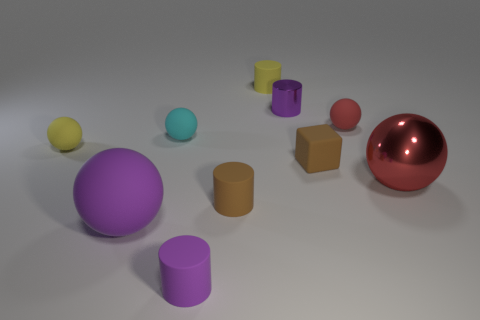Is there any other thing that is the same color as the small rubber block?
Offer a terse response. Yes. There is a cylinder that is the same color as the tiny block; what material is it?
Your answer should be compact. Rubber. The red metallic thing that is the same size as the purple ball is what shape?
Ensure brevity in your answer.  Sphere. What number of other objects are there of the same color as the metal sphere?
Your answer should be compact. 1. What number of cyan matte objects are there?
Offer a very short reply. 1. What number of matte things are right of the tiny purple metallic object and behind the brown cube?
Your response must be concise. 1. What material is the large red sphere?
Your answer should be compact. Metal. Is there a gray block?
Ensure brevity in your answer.  No. There is a big shiny ball to the right of the cyan rubber ball; what color is it?
Give a very brief answer. Red. There is a small purple cylinder that is behind the rubber thing on the right side of the brown rubber cube; how many large balls are to the right of it?
Offer a very short reply. 1. 